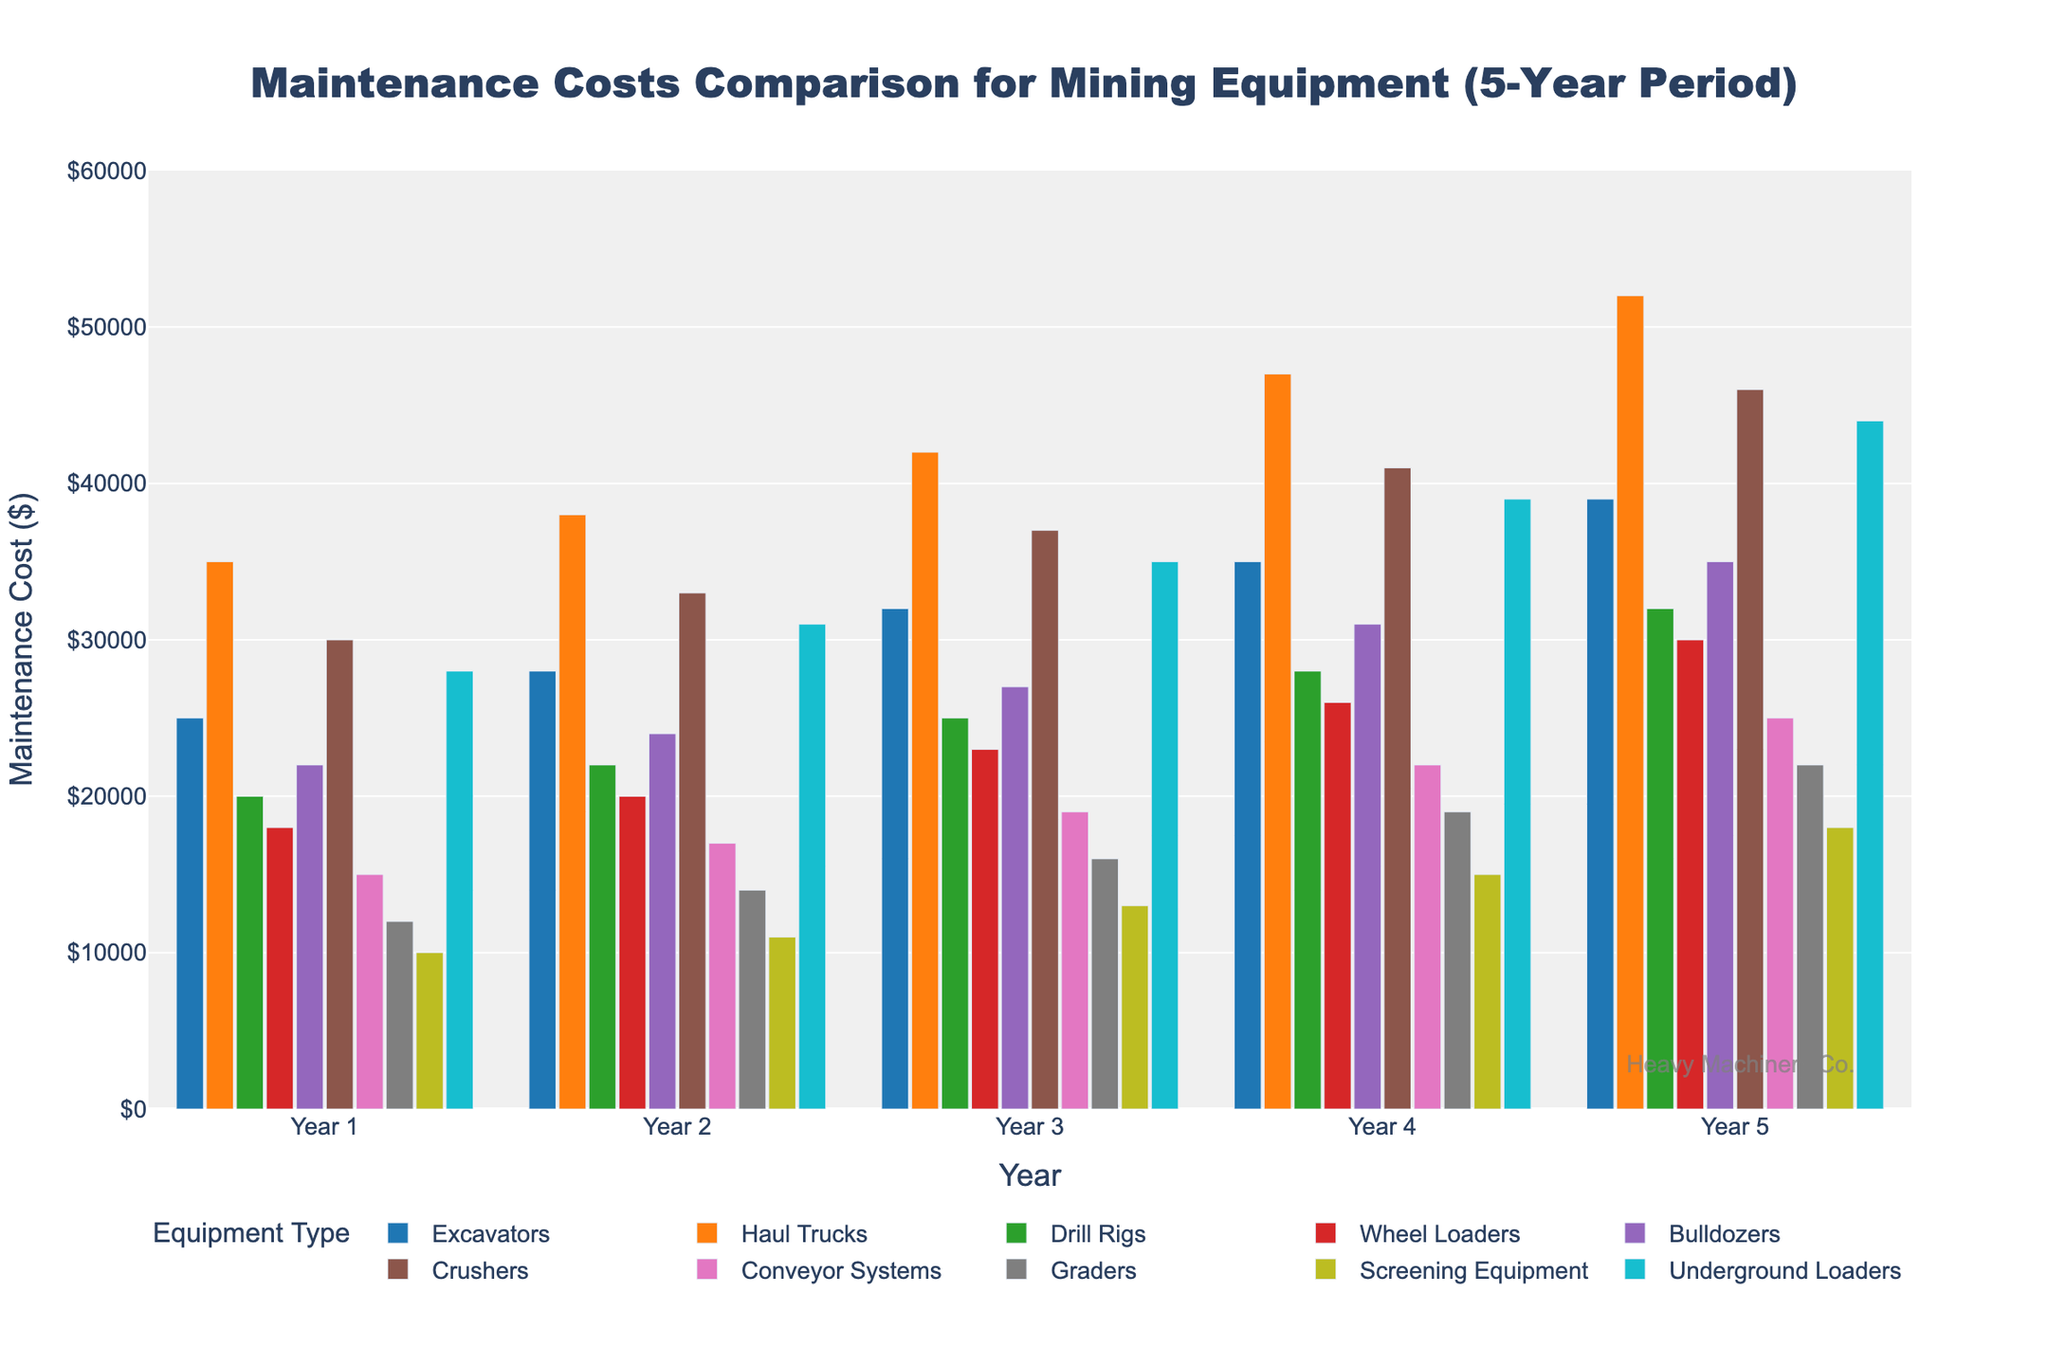Which equipment type had the highest maintenance cost in Year 3? Look at the bars corresponding to Year 3 and identify the tallest one. The tallest bar represents Haul Trucks with a maintenance cost of $42,000.
Answer: Haul Trucks What is the total maintenance cost for Crushers over the 5-year period? Sum the maintenance costs for Crushers for all 5 years: $30,000 (Year 1) + $33,000 (Year 2) + $37,000 (Year 3) + $41,000 (Year 4) + $46,000 (Year 5) = $187,000.
Answer: $187,000 Which equipment type had the lowest maintenance cost in Year 5, and what was the cost? Identify the shortest bar among all equipment types in Year 5. The shortest bar represents Screening Equipment with a maintenance cost of $18,000.
Answer: Screening Equipment, $18,000 How much higher was the maintenance cost for Wheel Loaders compared to Conveyor Systems in Year 4? Subtract the maintenance cost of Conveyor Systems in Year 4 from that of Wheel Loaders: $26,000 (Wheel Loaders) - $22,000 (Conveyor Systems) = $4,000.
Answer: $4,000 What is the average maintenance cost for Graders over the 5-year period? Sum the maintenance costs for Graders over all 5 years and divide by 5: ($12,000 + $14,000 + $16,000 + $19,000 + $22,000) / 5 = $83,000 / 5 = $16,600.
Answer: $16,600 Which equipment type showed the biggest increase in maintenance costs from Year 1 to Year 5? Calculate the difference in maintenance costs from Year 1 to Year 5 for each equipment type and find the largest difference: Haul Trucks had an increase of $52,000 (Year 5) - $35,000 (Year 1) = $17,000.
Answer: Haul Trucks For which year is the total maintenance cost across all equipment types the highest? Sum the maintenance costs for all equipment types for each year, then find the year with the highest total. Year 5 has the highest total: $39,000 (Excavators) + $52,000 (Haul Trucks) + $32,000 (Drill Rigs) + $30,000 (Wheel Loaders) + $35,000 (Bulldozers) + $46,000 (Crushers) + $25,000 (Conveyor Systems) + $22,000 (Graders) + $18,000 (Screening Equipment) + $44,000 (Underground Loaders) = $343,000.
Answer: Year 5 How does the maintenance cost of Bulldozers in Year 5 compare to Underground Loaders in the same year? Compare the heights of the bars for Bulldozers and Underground Loaders in Year 5. Bulldozers have a maintenance cost of $35,000, and Underground Loaders have a cost of $44,000, so Bulldozers' cost is lower.
Answer: Lower What is the average maintenance cost of Excavators for the first three years? Sum the maintenance costs of Excavators for Year 1, Year 2, and Year 3, then divide by 3: ($25,000 + $28,000 + $32,000) / 3 = $85,000 / 3 ≈ $28,333.
Answer: $28,333 